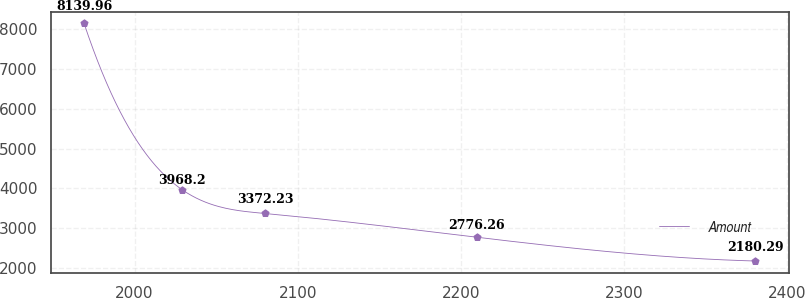Convert chart to OTSL. <chart><loc_0><loc_0><loc_500><loc_500><line_chart><ecel><fcel>Amount<nl><fcel>1969.1<fcel>8139.96<nl><fcel>2029.2<fcel>3968.2<nl><fcel>2080.22<fcel>3372.23<nl><fcel>2209.81<fcel>2776.26<nl><fcel>2380.41<fcel>2180.29<nl></chart> 